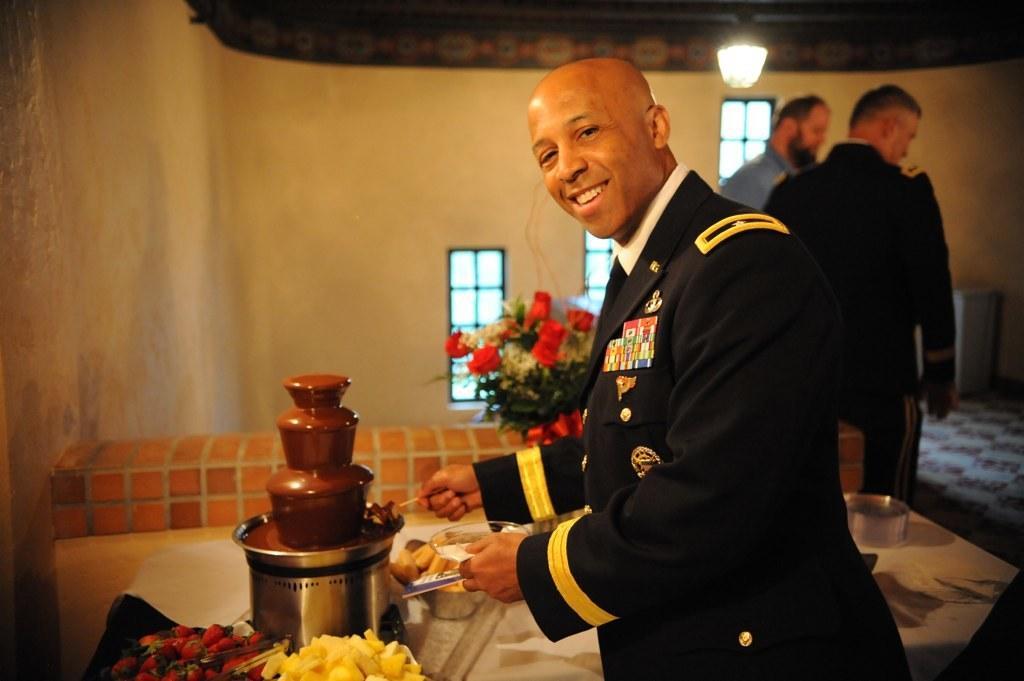How would you summarize this image in a sentence or two? At the bottom of the image on the left side there is a table with strawberries and some other fruit slices. Beside them there is a chocolate fountain machine and also there are some other things on the table. There is a man standing and holding an object in the hand. Behind them there are two men standing. In the background there is a wall with windows. At the top of the image there is lamp. 